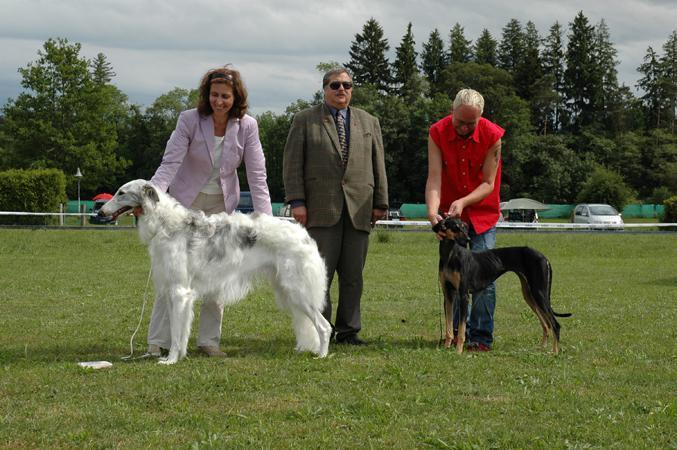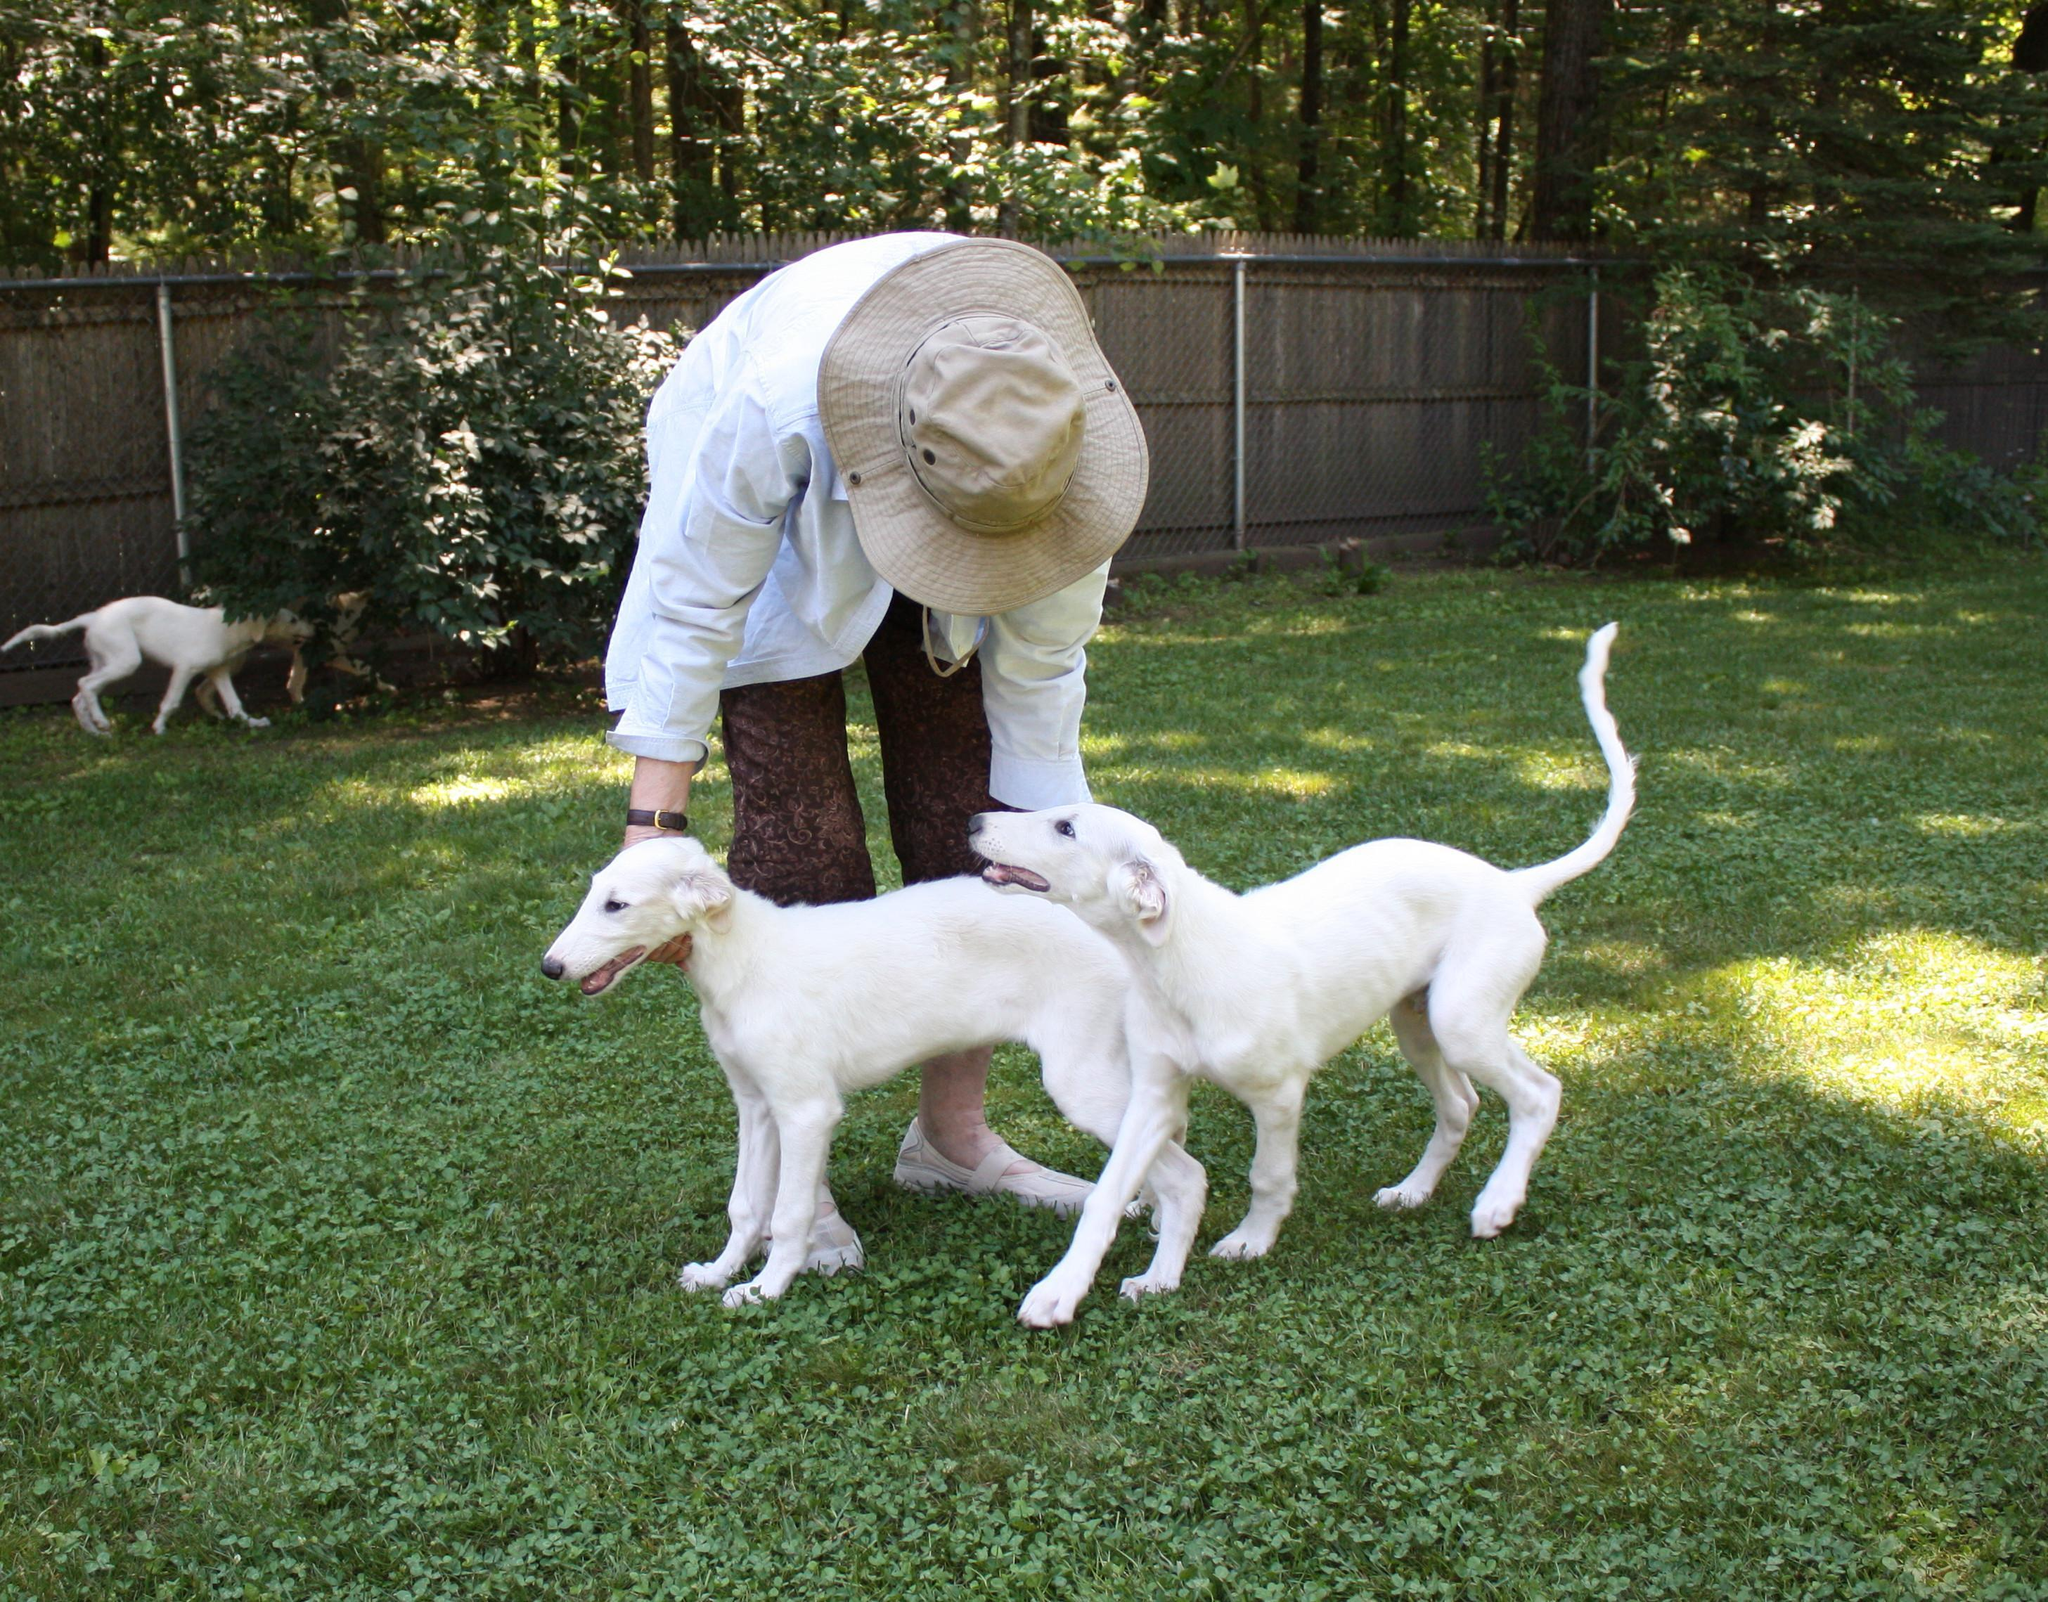The first image is the image on the left, the second image is the image on the right. For the images shown, is this caption "At least three people, including one in bright red, stand in a row behind dogs standing on grass." true? Answer yes or no. Yes. 